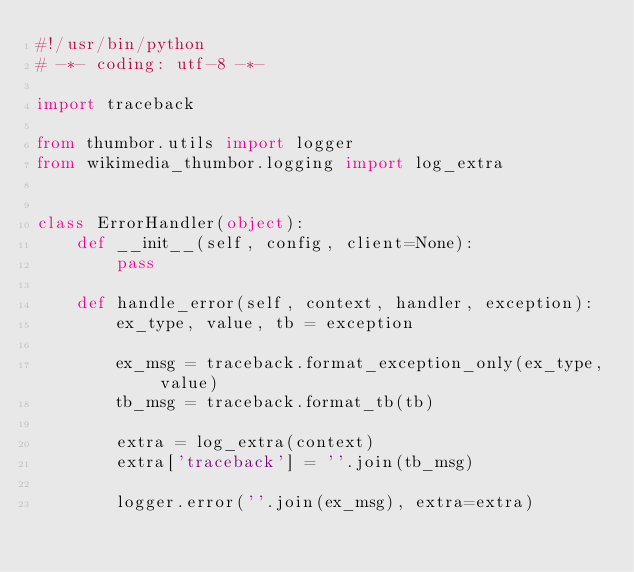<code> <loc_0><loc_0><loc_500><loc_500><_Python_>#!/usr/bin/python
# -*- coding: utf-8 -*-

import traceback

from thumbor.utils import logger
from wikimedia_thumbor.logging import log_extra


class ErrorHandler(object):
    def __init__(self, config, client=None):
        pass

    def handle_error(self, context, handler, exception):
        ex_type, value, tb = exception

        ex_msg = traceback.format_exception_only(ex_type, value)
        tb_msg = traceback.format_tb(tb)

        extra = log_extra(context)
        extra['traceback'] = ''.join(tb_msg)

        logger.error(''.join(ex_msg), extra=extra)
</code> 